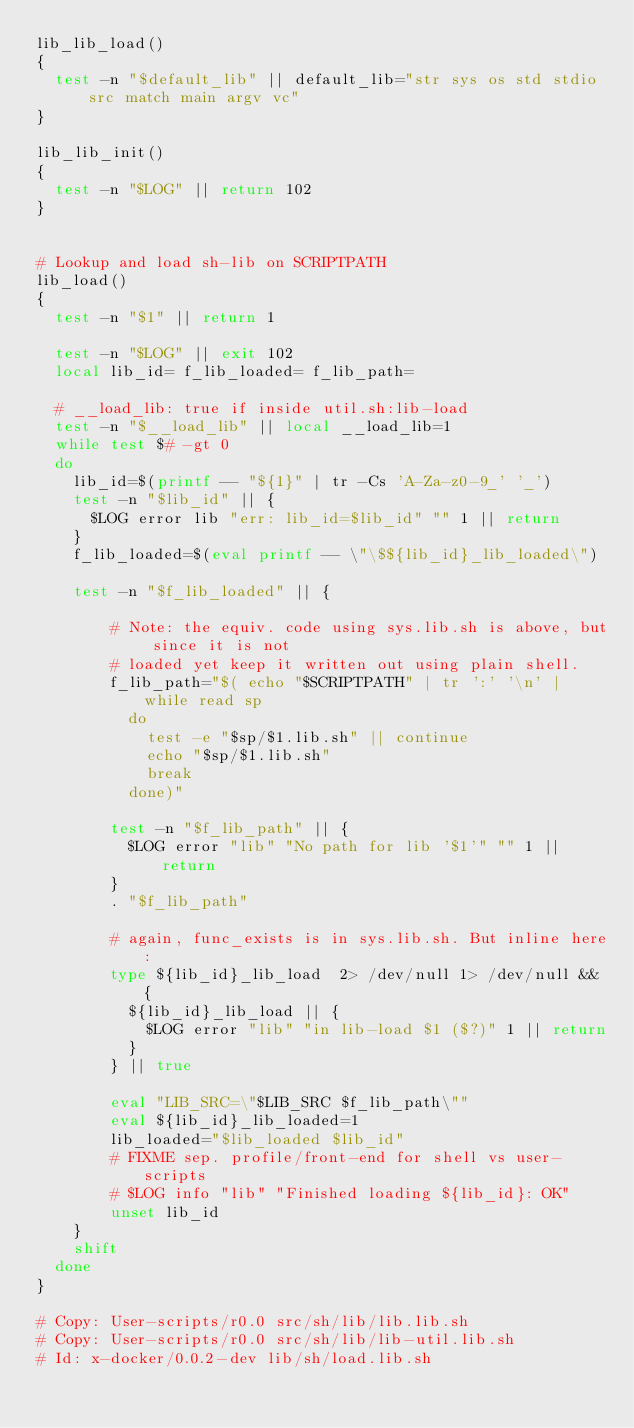<code> <loc_0><loc_0><loc_500><loc_500><_Bash_>lib_lib_load()
{
  test -n "$default_lib" || default_lib="str sys os std stdio src match main argv vc"
}

lib_lib_init()
{
  test -n "$LOG" || return 102
}


# Lookup and load sh-lib on SCRIPTPATH
lib_load()
{
  test -n "$1" || return 1

  test -n "$LOG" || exit 102
  local lib_id= f_lib_loaded= f_lib_path=

  # __load_lib: true if inside util.sh:lib-load
  test -n "$__load_lib" || local __load_lib=1
  while test $# -gt 0
  do
    lib_id=$(printf -- "${1}" | tr -Cs 'A-Za-z0-9_' '_')
    test -n "$lib_id" || {
      $LOG error lib "err: lib_id=$lib_id" "" 1 || return
    }
    f_lib_loaded=$(eval printf -- \"\$${lib_id}_lib_loaded\")

    test -n "$f_lib_loaded" || {

        # Note: the equiv. code using sys.lib.sh is above, but since it is not
        # loaded yet keep it written out using plain shell.
        f_lib_path="$( echo "$SCRIPTPATH" | tr ':' '\n' | while read sp
          do
            test -e "$sp/$1.lib.sh" || continue
            echo "$sp/$1.lib.sh"
            break
          done)"

        test -n "$f_lib_path" || {
          $LOG error "lib" "No path for lib '$1'" "" 1 || return
        }
        . "$f_lib_path"

        # again, func_exists is in sys.lib.sh. But inline here:
        type ${lib_id}_lib_load  2> /dev/null 1> /dev/null && {
          ${lib_id}_lib_load || {
            $LOG error "lib" "in lib-load $1 ($?)" 1 || return
          }
        } || true

        eval "LIB_SRC=\"$LIB_SRC $f_lib_path\""
        eval ${lib_id}_lib_loaded=1
        lib_loaded="$lib_loaded $lib_id"
        # FIXME sep. profile/front-end for shell vs user-scripts
        # $LOG info "lib" "Finished loading ${lib_id}: OK"
        unset lib_id
    }
    shift
  done
}

# Copy: User-scripts/r0.0 src/sh/lib/lib.lib.sh
# Copy: User-scripts/r0.0 src/sh/lib/lib-util.lib.sh
# Id: x-docker/0.0.2-dev lib/sh/load.lib.sh
</code> 